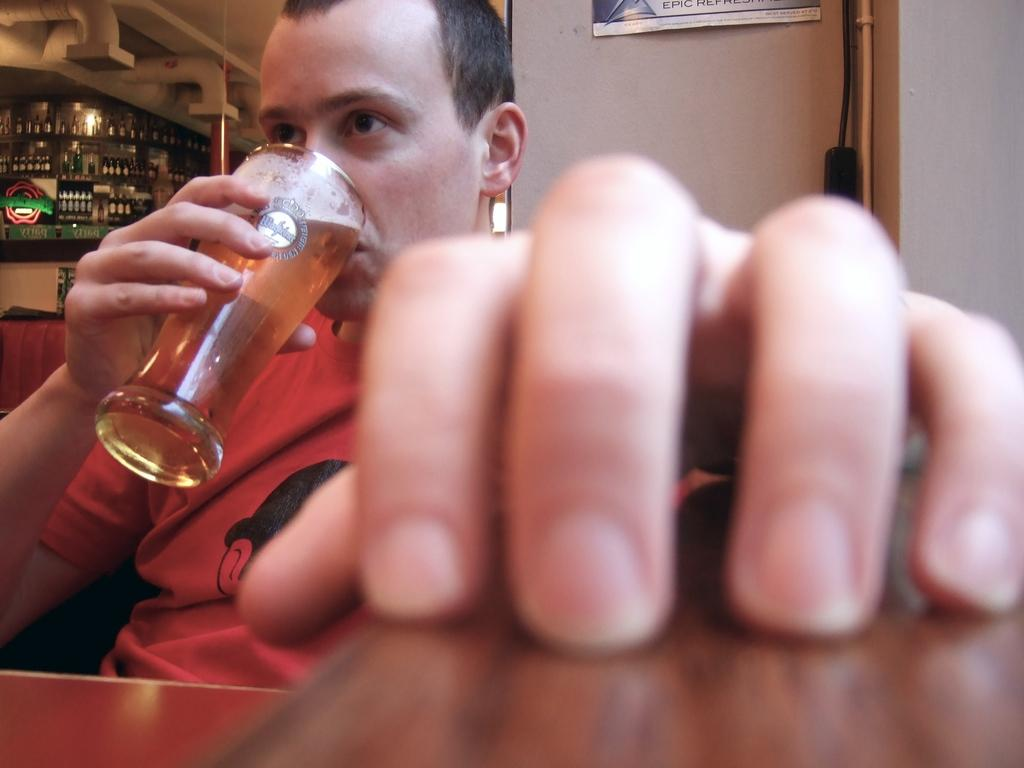What is the person in the image doing? The person is sitting on a chair and drinking from a wine glass. What is in front of the person? There is a table in front of the person. What is behind the person? There is a wall behind the person. What else can be seen related to wine in the image? There are wine bottles visible at the back. How does the person compare the taste of the wine with the crowd's opinion in the image? There is no mention of a crowd or any comparison of the wine's taste in the image. 